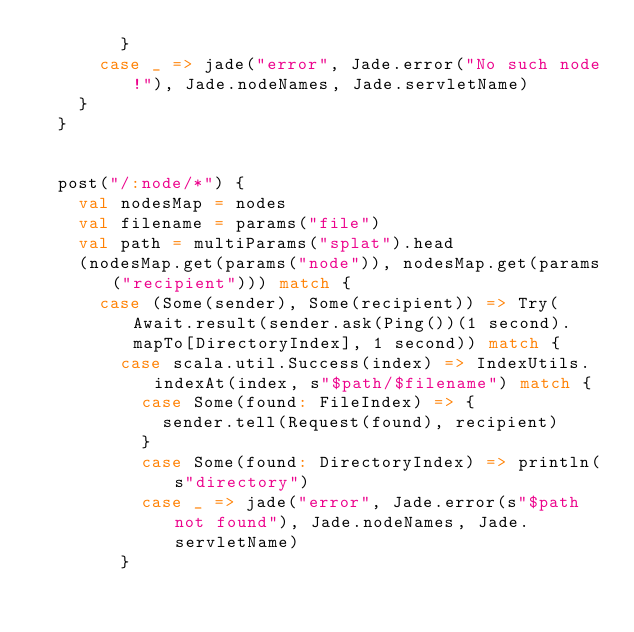Convert code to text. <code><loc_0><loc_0><loc_500><loc_500><_Scala_>        }
      case _ => jade("error", Jade.error("No such node!"), Jade.nodeNames, Jade.servletName)
    }
  }


  post("/:node/*") {
    val nodesMap = nodes
    val filename = params("file")
    val path = multiParams("splat").head
    (nodesMap.get(params("node")), nodesMap.get(params("recipient"))) match {
      case (Some(sender), Some(recipient)) => Try(Await.result(sender.ask(Ping())(1 second).mapTo[DirectoryIndex], 1 second)) match {
        case scala.util.Success(index) => IndexUtils.indexAt(index, s"$path/$filename") match {
          case Some(found: FileIndex) => {
            sender.tell(Request(found), recipient)
          }
          case Some(found: DirectoryIndex) => println(s"directory")
          case _ => jade("error", Jade.error(s"$path not found"), Jade.nodeNames, Jade.servletName)
        }</code> 